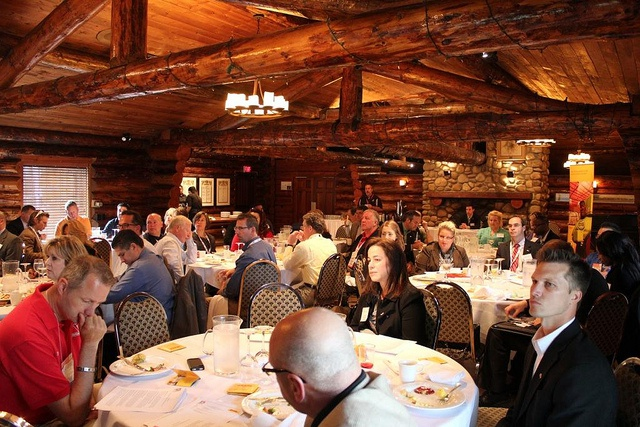Describe the objects in this image and their specific colors. I can see dining table in maroon, ivory, and tan tones, people in maroon, black, tan, darkgray, and brown tones, people in maroon and brown tones, people in maroon, lightgray, darkgray, and gray tones, and people in maroon, black, and tan tones in this image. 